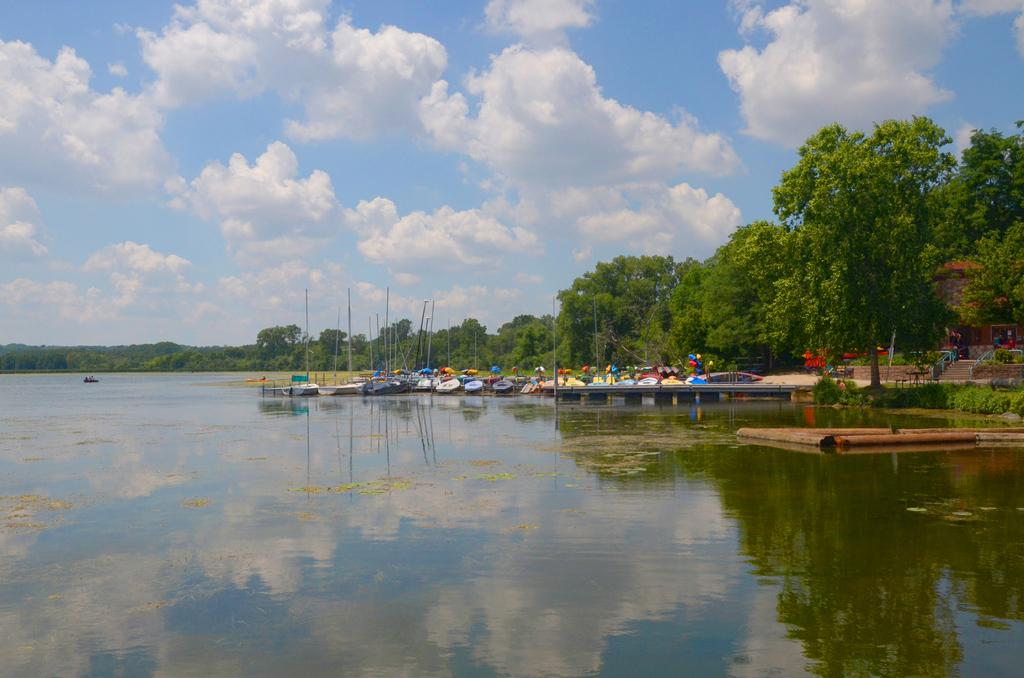What body of water is visible in the front of the image? There is a lake in the front of the image. What can be seen in the back of the image? There are ships in the back of the image. What type of vegetation is visible in the background of the image? There are trees in the background of the image. What is visible in the sky in the image? The sky is visible in the image, and clouds are present. What company is responsible for the fight between the ships in the image? There is no fight between the ships in the image, and no company is mentioned. How does the cover of the lake affect the visibility of the ships in the image? There is no cover on the lake in the image, so this question cannot be answered. 